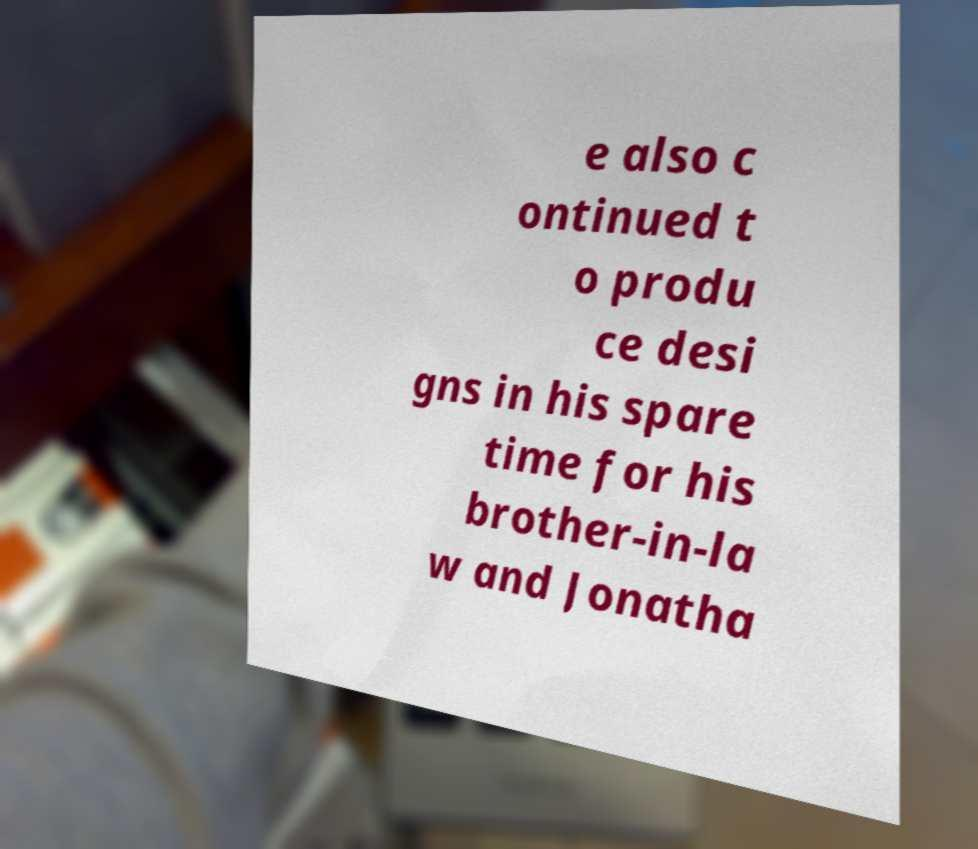Can you read and provide the text displayed in the image?This photo seems to have some interesting text. Can you extract and type it out for me? e also c ontinued t o produ ce desi gns in his spare time for his brother-in-la w and Jonatha 